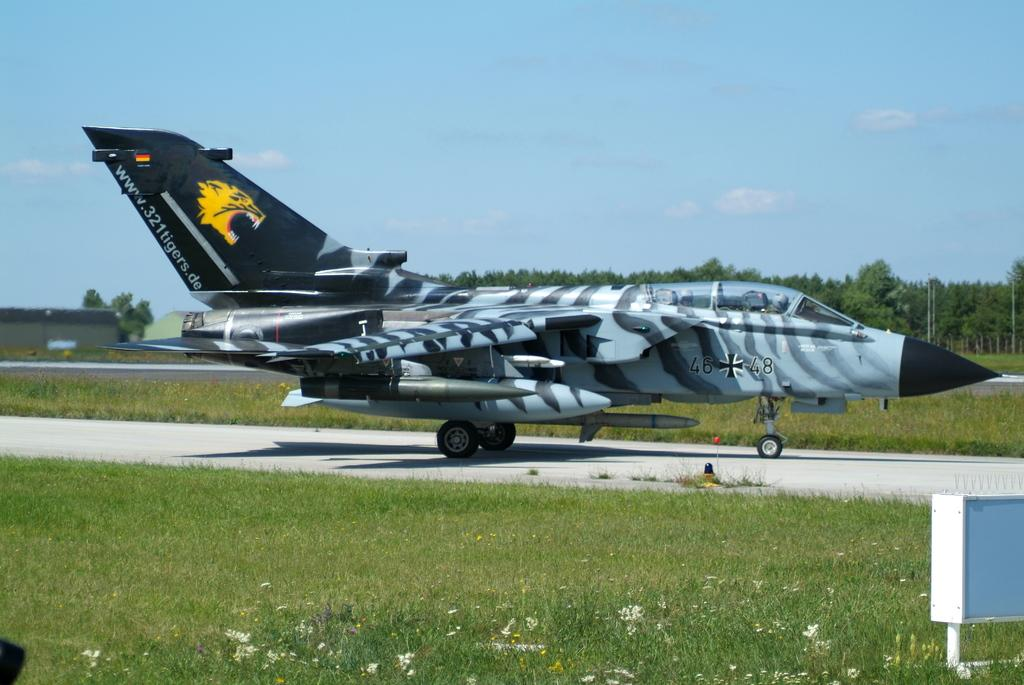<image>
Create a compact narrative representing the image presented. The number 48 is on a gray, white, and black plane on the runway. 